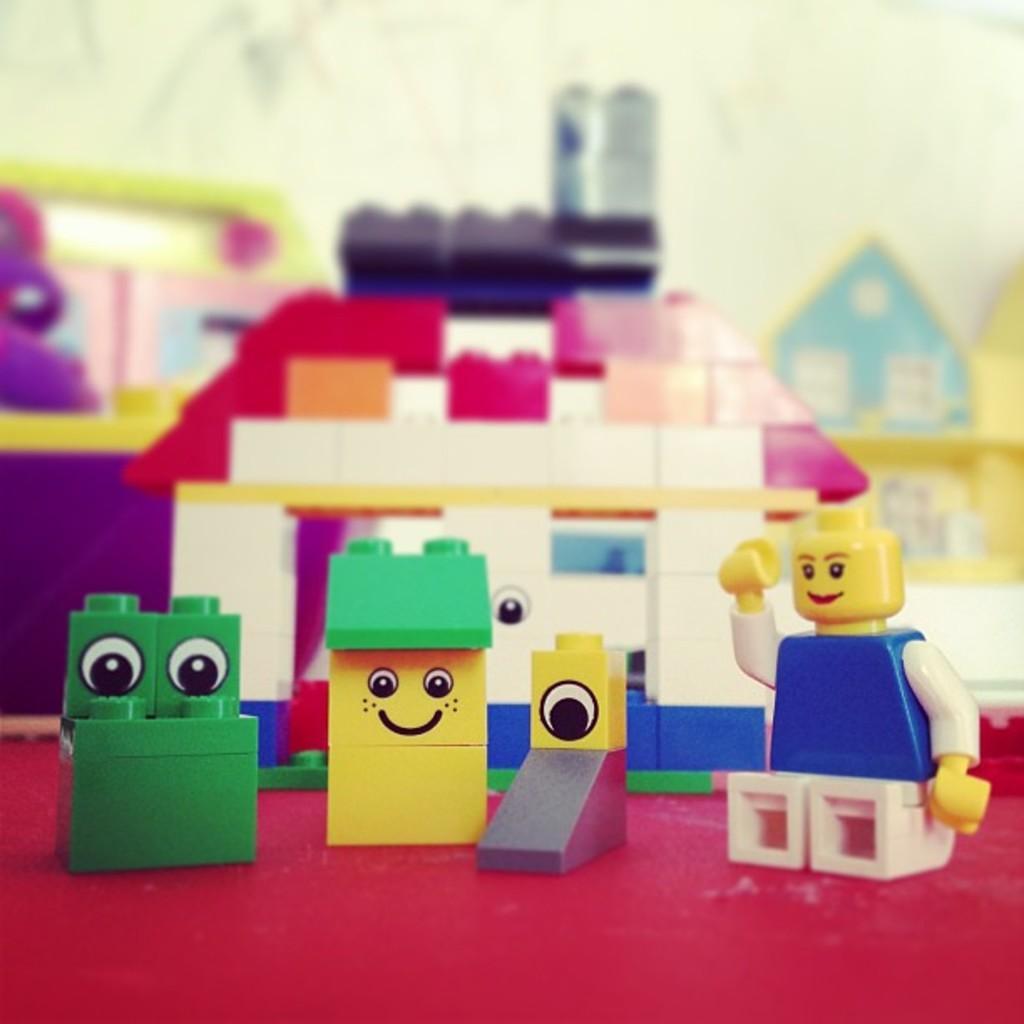Can you describe this image briefly? There are toys in different colors on the red color surface. And the background is blurred. 